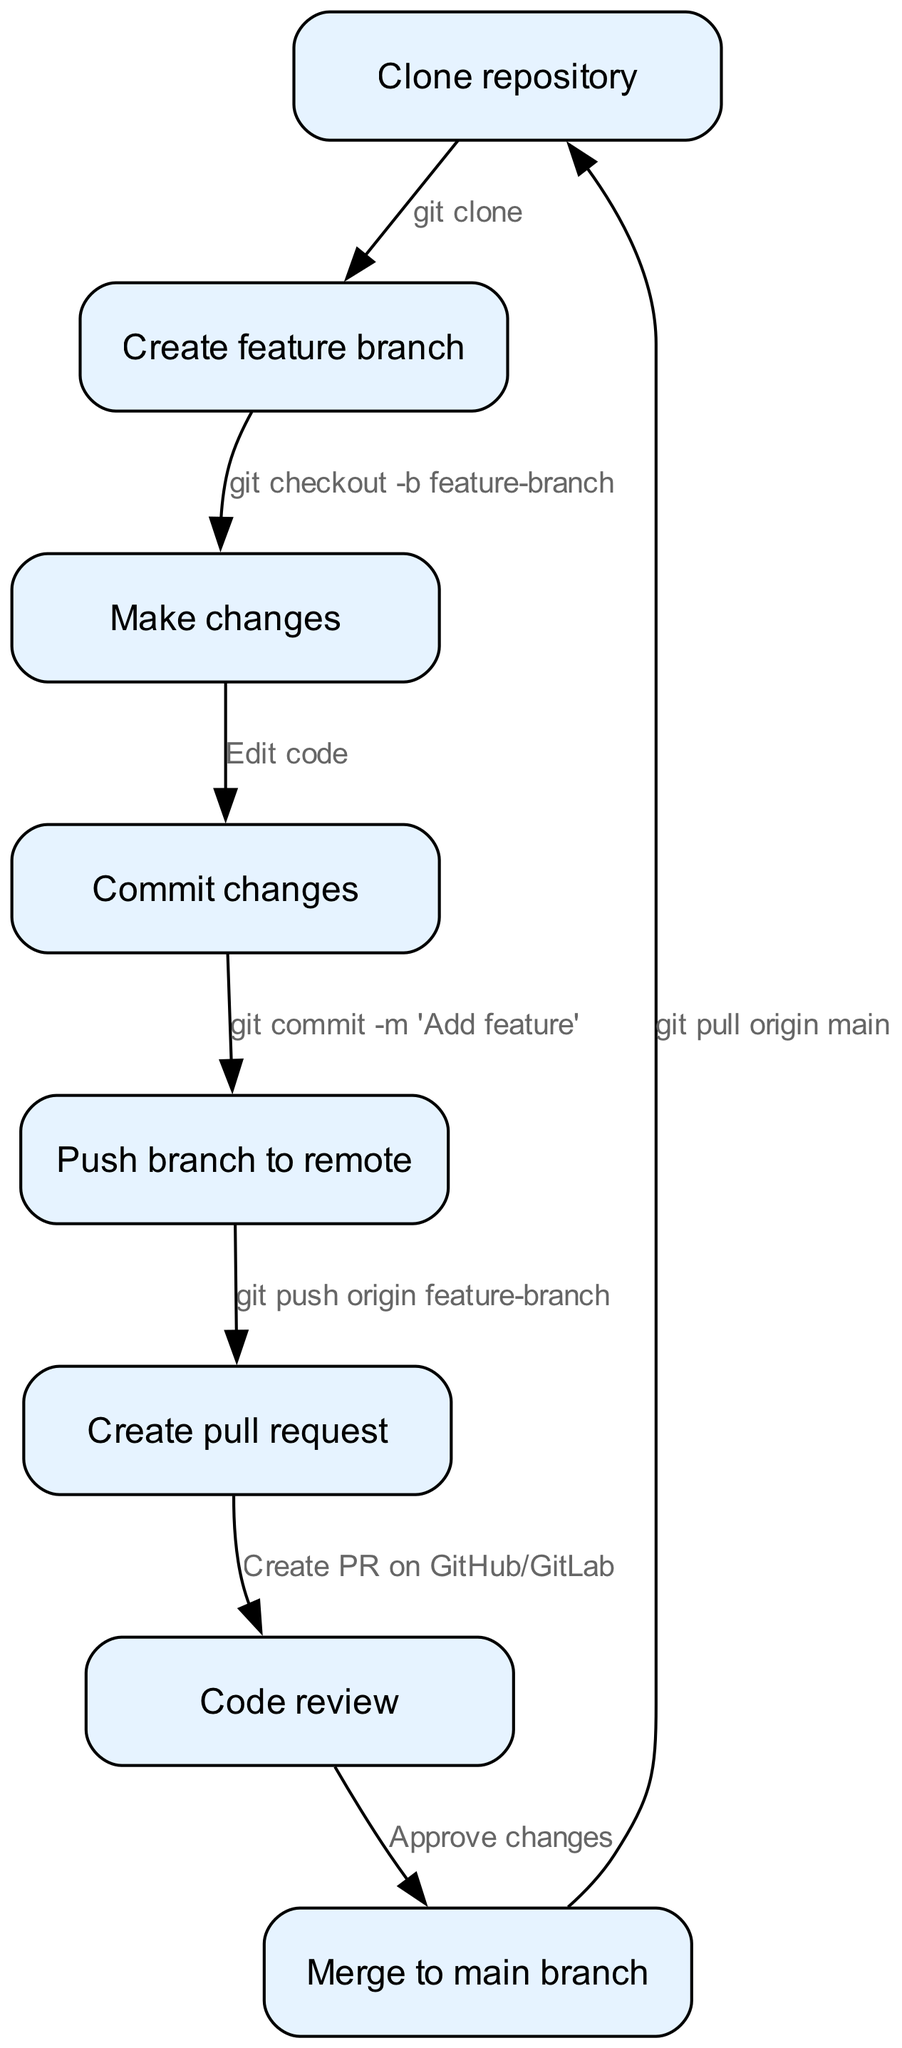What is the first step in the Git workflow? The first step is represented by the node labeled "Clone repository," which indicates the initial action in the Git workflow.
Answer: Clone repository How many nodes are present in the diagram? By counting the nodes listed in the data, we see that there are a total of eight unique nodes in the diagram.
Answer: Eight What command is used to create a feature branch? The node connecting from "Create feature branch" indicates the command associated with this step, which is "git checkout -b feature-branch."
Answer: git checkout -b feature-branch What happens after making changes? Following the "Make changes" node, the next step directs to "Commit changes," which signifies what occurs after alterations are made to the code.
Answer: Commit changes How many edges are there in the diagram? By counting the edges listed in the data, we determine that there are a total of eight connections between the nodes in the diagram.
Answer: Eight What is the relationship between "Create pull request" and "Code review"? These two nodes are directly connected in the diagram, indicating a sequential process where the creation of a pull request leads to a code review.
Answer: Sequential process What is the final action in the Git workflow? According to the flow of the diagram, the last step returns to the "Clone repository" node, indicating that the workflow completes at this point.
Answer: Clone repository What is the command used to push the branch to remote? The edge leading to the node "Create pull request" specifies that the command to be executed is "git push origin feature-branch."
Answer: git push origin feature-branch What follows the "Approve changes" action? After the approval of changes, the next action is to "Merge to main branch," illustrating the subsequent step in the workflow following approval.
Answer: Merge to main branch 